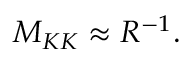<formula> <loc_0><loc_0><loc_500><loc_500>M _ { K K } \approx R ^ { - 1 } .</formula> 